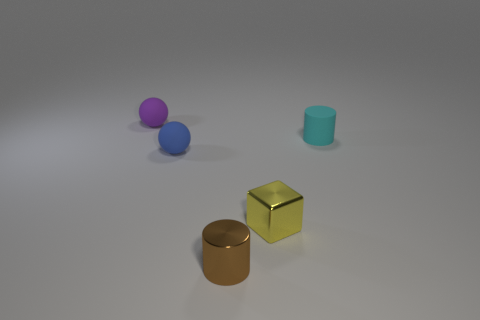Add 3 tiny balls. How many objects exist? 8 Add 5 tiny brown metallic objects. How many tiny brown metallic objects are left? 6 Add 5 purple spheres. How many purple spheres exist? 6 Subtract 1 purple spheres. How many objects are left? 4 Subtract all cylinders. How many objects are left? 3 Subtract all yellow metallic cylinders. Subtract all purple rubber spheres. How many objects are left? 4 